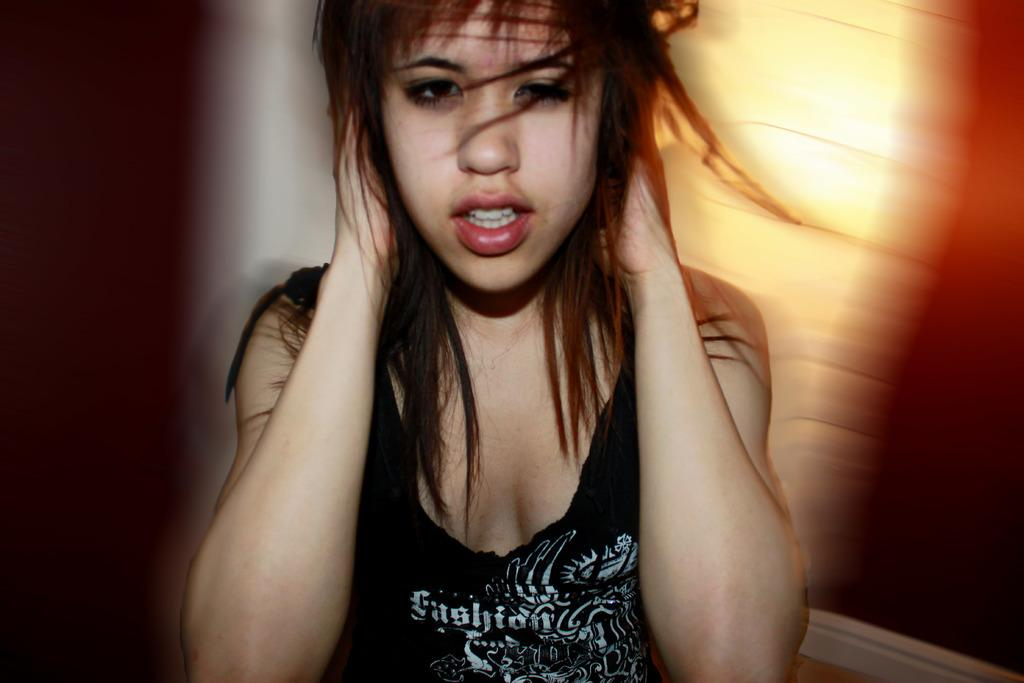Who is the main subject in the image? There is a girl in the image. Can you describe the background of the image? The background of the image is blurry. What type of bat is flying in the middle of the image? There is no bat present in the image; it only features a girl with a blurry background. 